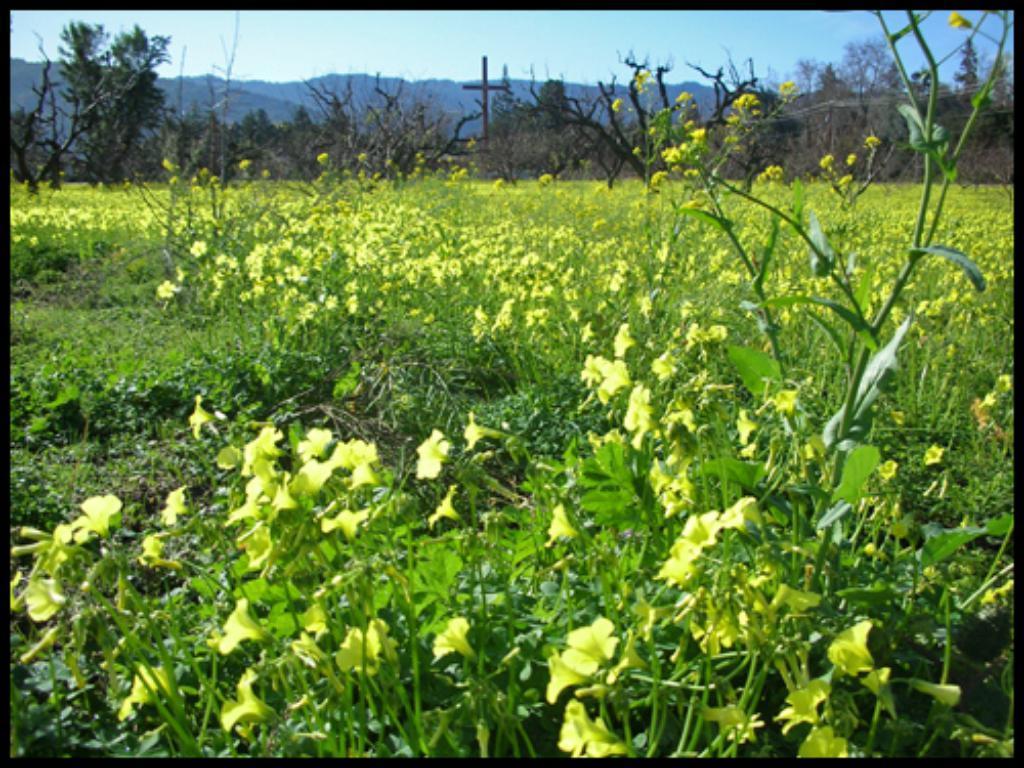In one or two sentences, can you explain what this image depicts? In the image we can see some flowers and plants. At the top of the image there are some trees and poles and hills and sky. 